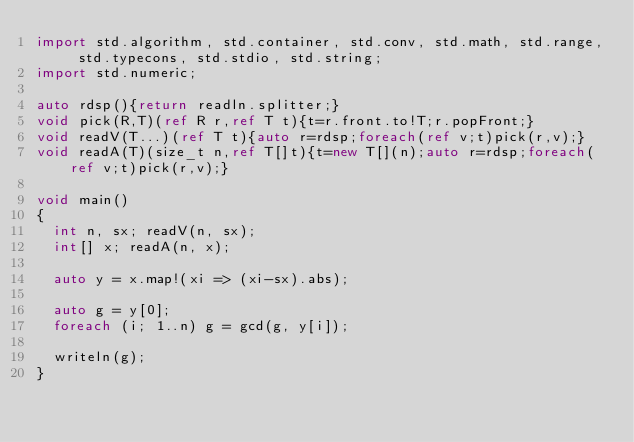Convert code to text. <code><loc_0><loc_0><loc_500><loc_500><_D_>import std.algorithm, std.container, std.conv, std.math, std.range, std.typecons, std.stdio, std.string;
import std.numeric;

auto rdsp(){return readln.splitter;}
void pick(R,T)(ref R r,ref T t){t=r.front.to!T;r.popFront;}
void readV(T...)(ref T t){auto r=rdsp;foreach(ref v;t)pick(r,v);}
void readA(T)(size_t n,ref T[]t){t=new T[](n);auto r=rdsp;foreach(ref v;t)pick(r,v);}

void main()
{
  int n, sx; readV(n, sx);
  int[] x; readA(n, x);

  auto y = x.map!(xi => (xi-sx).abs);

  auto g = y[0];
  foreach (i; 1..n) g = gcd(g, y[i]);

  writeln(g);
}
</code> 